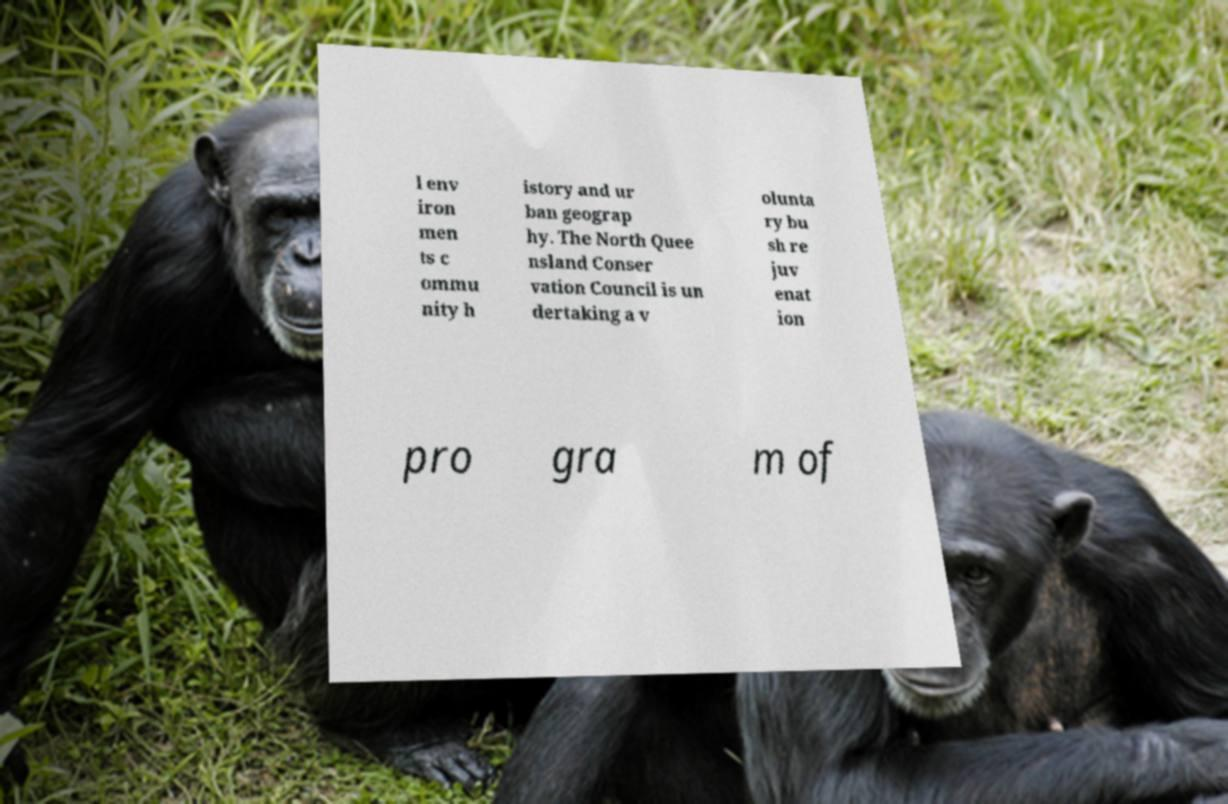Can you read and provide the text displayed in the image?This photo seems to have some interesting text. Can you extract and type it out for me? l env iron men ts c ommu nity h istory and ur ban geograp hy. The North Quee nsland Conser vation Council is un dertaking a v olunta ry bu sh re juv enat ion pro gra m of 